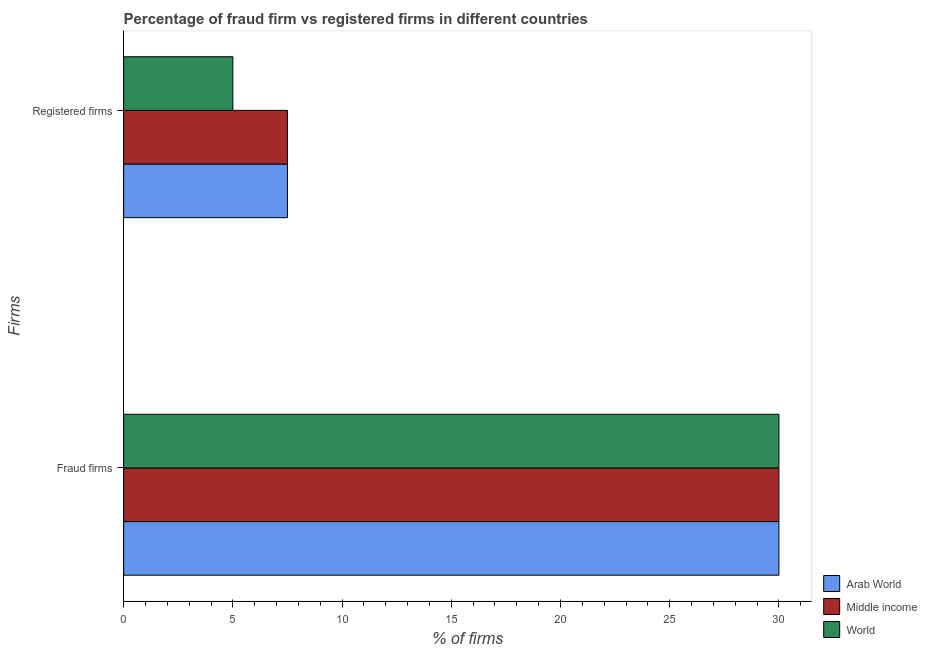Are the number of bars per tick equal to the number of legend labels?
Provide a succinct answer. Yes. How many bars are there on the 2nd tick from the top?
Ensure brevity in your answer.  3. How many bars are there on the 2nd tick from the bottom?
Your answer should be compact. 3. What is the label of the 2nd group of bars from the top?
Ensure brevity in your answer.  Fraud firms. Across all countries, what is the maximum percentage of fraud firms?
Provide a succinct answer. 30. Across all countries, what is the minimum percentage of fraud firms?
Your response must be concise. 30. In which country was the percentage of registered firms maximum?
Give a very brief answer. Arab World. In which country was the percentage of registered firms minimum?
Provide a short and direct response. World. What is the difference between the percentage of registered firms in Arab World and that in World?
Make the answer very short. 2.5. What is the difference between the percentage of registered firms in Middle income and the percentage of fraud firms in World?
Your answer should be very brief. -22.5. What is the average percentage of registered firms per country?
Your response must be concise. 6.67. Is the percentage of fraud firms in Arab World less than that in World?
Make the answer very short. No. What does the 1st bar from the top in Registered firms represents?
Your answer should be very brief. World. What does the 1st bar from the bottom in Fraud firms represents?
Provide a short and direct response. Arab World. Are all the bars in the graph horizontal?
Your answer should be very brief. Yes. How many countries are there in the graph?
Your response must be concise. 3. What is the difference between two consecutive major ticks on the X-axis?
Give a very brief answer. 5. Does the graph contain any zero values?
Make the answer very short. No. Does the graph contain grids?
Keep it short and to the point. No. Where does the legend appear in the graph?
Provide a short and direct response. Bottom right. How are the legend labels stacked?
Make the answer very short. Vertical. What is the title of the graph?
Keep it short and to the point. Percentage of fraud firm vs registered firms in different countries. What is the label or title of the X-axis?
Keep it short and to the point. % of firms. What is the label or title of the Y-axis?
Your answer should be compact. Firms. What is the % of firms of Arab World in Fraud firms?
Keep it short and to the point. 30. What is the % of firms of World in Fraud firms?
Offer a terse response. 30. What is the % of firms of Arab World in Registered firms?
Your answer should be compact. 7.5. What is the % of firms of Middle income in Registered firms?
Make the answer very short. 7.5. Across all Firms, what is the maximum % of firms in Arab World?
Your answer should be very brief. 30. Across all Firms, what is the maximum % of firms of Middle income?
Ensure brevity in your answer.  30. Across all Firms, what is the minimum % of firms in Arab World?
Keep it short and to the point. 7.5. Across all Firms, what is the minimum % of firms in World?
Your response must be concise. 5. What is the total % of firms of Arab World in the graph?
Provide a short and direct response. 37.5. What is the total % of firms of Middle income in the graph?
Your response must be concise. 37.5. What is the difference between the % of firms of Middle income in Fraud firms and that in Registered firms?
Offer a terse response. 22.5. What is the average % of firms in Arab World per Firms?
Offer a very short reply. 18.75. What is the average % of firms of Middle income per Firms?
Offer a very short reply. 18.75. What is the difference between the % of firms of Arab World and % of firms of Middle income in Fraud firms?
Provide a short and direct response. 0. What is the difference between the % of firms of Arab World and % of firms of World in Fraud firms?
Make the answer very short. 0. What is the ratio of the % of firms of Arab World in Fraud firms to that in Registered firms?
Your answer should be compact. 4. What is the ratio of the % of firms of Middle income in Fraud firms to that in Registered firms?
Your response must be concise. 4. What is the ratio of the % of firms of World in Fraud firms to that in Registered firms?
Ensure brevity in your answer.  6. What is the difference between the highest and the second highest % of firms of World?
Your response must be concise. 25. What is the difference between the highest and the lowest % of firms of World?
Offer a terse response. 25. 